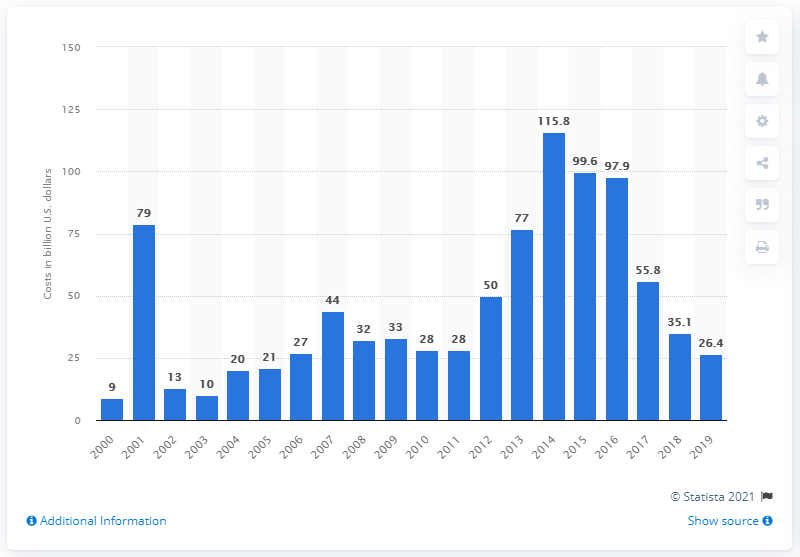Highlight a few significant elements in this photo. In 2019, the total cost of terrorism was 26.4 billion dollars. The recorded lowest amount of costs from terrorism was in 2005. In 2014, the highest economic cost from terrorism was estimated to be $115.8 billion. 